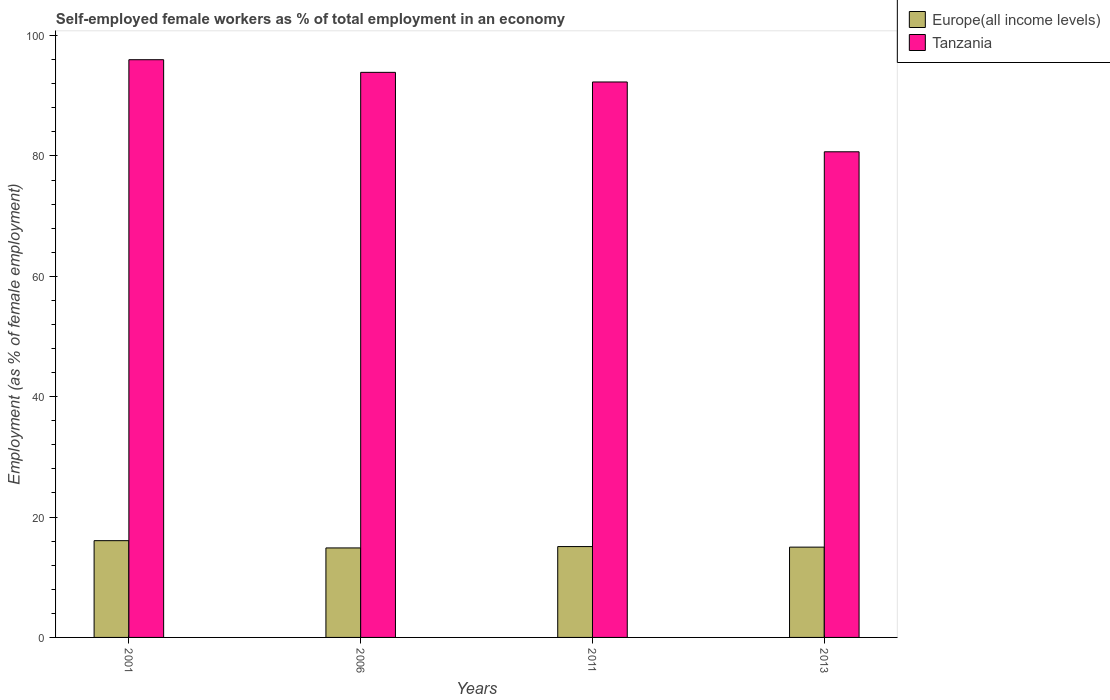How many different coloured bars are there?
Provide a short and direct response. 2. How many groups of bars are there?
Your answer should be very brief. 4. Are the number of bars on each tick of the X-axis equal?
Offer a very short reply. Yes. How many bars are there on the 4th tick from the right?
Give a very brief answer. 2. What is the label of the 1st group of bars from the left?
Ensure brevity in your answer.  2001. What is the percentage of self-employed female workers in Tanzania in 2011?
Provide a succinct answer. 92.3. Across all years, what is the maximum percentage of self-employed female workers in Tanzania?
Offer a very short reply. 96. Across all years, what is the minimum percentage of self-employed female workers in Europe(all income levels)?
Your response must be concise. 14.87. In which year was the percentage of self-employed female workers in Tanzania minimum?
Keep it short and to the point. 2013. What is the total percentage of self-employed female workers in Tanzania in the graph?
Your answer should be compact. 362.9. What is the difference between the percentage of self-employed female workers in Europe(all income levels) in 2001 and that in 2006?
Provide a short and direct response. 1.21. What is the difference between the percentage of self-employed female workers in Tanzania in 2011 and the percentage of self-employed female workers in Europe(all income levels) in 2001?
Ensure brevity in your answer.  76.22. What is the average percentage of self-employed female workers in Tanzania per year?
Offer a very short reply. 90.73. In the year 2011, what is the difference between the percentage of self-employed female workers in Tanzania and percentage of self-employed female workers in Europe(all income levels)?
Your answer should be very brief. 77.2. What is the ratio of the percentage of self-employed female workers in Europe(all income levels) in 2001 to that in 2013?
Provide a succinct answer. 1.07. Is the difference between the percentage of self-employed female workers in Tanzania in 2001 and 2006 greater than the difference between the percentage of self-employed female workers in Europe(all income levels) in 2001 and 2006?
Your answer should be compact. Yes. What is the difference between the highest and the second highest percentage of self-employed female workers in Europe(all income levels)?
Make the answer very short. 0.98. What is the difference between the highest and the lowest percentage of self-employed female workers in Europe(all income levels)?
Keep it short and to the point. 1.21. In how many years, is the percentage of self-employed female workers in Tanzania greater than the average percentage of self-employed female workers in Tanzania taken over all years?
Offer a very short reply. 3. What does the 1st bar from the left in 2013 represents?
Your answer should be compact. Europe(all income levels). What does the 2nd bar from the right in 2001 represents?
Give a very brief answer. Europe(all income levels). How many bars are there?
Keep it short and to the point. 8. Are the values on the major ticks of Y-axis written in scientific E-notation?
Provide a short and direct response. No. Does the graph contain any zero values?
Your answer should be very brief. No. Does the graph contain grids?
Your answer should be very brief. No. How many legend labels are there?
Make the answer very short. 2. How are the legend labels stacked?
Provide a succinct answer. Vertical. What is the title of the graph?
Your answer should be compact. Self-employed female workers as % of total employment in an economy. Does "Belarus" appear as one of the legend labels in the graph?
Provide a short and direct response. No. What is the label or title of the Y-axis?
Provide a succinct answer. Employment (as % of female employment). What is the Employment (as % of female employment) of Europe(all income levels) in 2001?
Offer a terse response. 16.08. What is the Employment (as % of female employment) in Tanzania in 2001?
Provide a short and direct response. 96. What is the Employment (as % of female employment) in Europe(all income levels) in 2006?
Keep it short and to the point. 14.87. What is the Employment (as % of female employment) of Tanzania in 2006?
Your answer should be compact. 93.9. What is the Employment (as % of female employment) of Europe(all income levels) in 2011?
Make the answer very short. 15.1. What is the Employment (as % of female employment) of Tanzania in 2011?
Make the answer very short. 92.3. What is the Employment (as % of female employment) in Europe(all income levels) in 2013?
Offer a very short reply. 15. What is the Employment (as % of female employment) of Tanzania in 2013?
Keep it short and to the point. 80.7. Across all years, what is the maximum Employment (as % of female employment) in Europe(all income levels)?
Make the answer very short. 16.08. Across all years, what is the maximum Employment (as % of female employment) in Tanzania?
Make the answer very short. 96. Across all years, what is the minimum Employment (as % of female employment) of Europe(all income levels)?
Your response must be concise. 14.87. Across all years, what is the minimum Employment (as % of female employment) of Tanzania?
Give a very brief answer. 80.7. What is the total Employment (as % of female employment) of Europe(all income levels) in the graph?
Provide a short and direct response. 61.05. What is the total Employment (as % of female employment) in Tanzania in the graph?
Provide a short and direct response. 362.9. What is the difference between the Employment (as % of female employment) in Europe(all income levels) in 2001 and that in 2006?
Offer a terse response. 1.21. What is the difference between the Employment (as % of female employment) of Tanzania in 2001 and that in 2006?
Your answer should be very brief. 2.1. What is the difference between the Employment (as % of female employment) of Europe(all income levels) in 2001 and that in 2011?
Your answer should be very brief. 0.98. What is the difference between the Employment (as % of female employment) of Tanzania in 2001 and that in 2011?
Make the answer very short. 3.7. What is the difference between the Employment (as % of female employment) of Europe(all income levels) in 2001 and that in 2013?
Provide a short and direct response. 1.08. What is the difference between the Employment (as % of female employment) of Europe(all income levels) in 2006 and that in 2011?
Provide a short and direct response. -0.23. What is the difference between the Employment (as % of female employment) in Europe(all income levels) in 2006 and that in 2013?
Provide a succinct answer. -0.13. What is the difference between the Employment (as % of female employment) in Europe(all income levels) in 2011 and that in 2013?
Provide a succinct answer. 0.1. What is the difference between the Employment (as % of female employment) of Tanzania in 2011 and that in 2013?
Give a very brief answer. 11.6. What is the difference between the Employment (as % of female employment) in Europe(all income levels) in 2001 and the Employment (as % of female employment) in Tanzania in 2006?
Make the answer very short. -77.82. What is the difference between the Employment (as % of female employment) of Europe(all income levels) in 2001 and the Employment (as % of female employment) of Tanzania in 2011?
Keep it short and to the point. -76.22. What is the difference between the Employment (as % of female employment) of Europe(all income levels) in 2001 and the Employment (as % of female employment) of Tanzania in 2013?
Provide a short and direct response. -64.62. What is the difference between the Employment (as % of female employment) in Europe(all income levels) in 2006 and the Employment (as % of female employment) in Tanzania in 2011?
Give a very brief answer. -77.43. What is the difference between the Employment (as % of female employment) in Europe(all income levels) in 2006 and the Employment (as % of female employment) in Tanzania in 2013?
Your response must be concise. -65.83. What is the difference between the Employment (as % of female employment) of Europe(all income levels) in 2011 and the Employment (as % of female employment) of Tanzania in 2013?
Offer a very short reply. -65.6. What is the average Employment (as % of female employment) of Europe(all income levels) per year?
Keep it short and to the point. 15.26. What is the average Employment (as % of female employment) of Tanzania per year?
Your answer should be very brief. 90.72. In the year 2001, what is the difference between the Employment (as % of female employment) of Europe(all income levels) and Employment (as % of female employment) of Tanzania?
Offer a terse response. -79.92. In the year 2006, what is the difference between the Employment (as % of female employment) in Europe(all income levels) and Employment (as % of female employment) in Tanzania?
Your answer should be compact. -79.03. In the year 2011, what is the difference between the Employment (as % of female employment) of Europe(all income levels) and Employment (as % of female employment) of Tanzania?
Your answer should be compact. -77.2. In the year 2013, what is the difference between the Employment (as % of female employment) of Europe(all income levels) and Employment (as % of female employment) of Tanzania?
Your response must be concise. -65.7. What is the ratio of the Employment (as % of female employment) of Europe(all income levels) in 2001 to that in 2006?
Offer a terse response. 1.08. What is the ratio of the Employment (as % of female employment) of Tanzania in 2001 to that in 2006?
Ensure brevity in your answer.  1.02. What is the ratio of the Employment (as % of female employment) of Europe(all income levels) in 2001 to that in 2011?
Offer a terse response. 1.06. What is the ratio of the Employment (as % of female employment) of Tanzania in 2001 to that in 2011?
Offer a very short reply. 1.04. What is the ratio of the Employment (as % of female employment) in Europe(all income levels) in 2001 to that in 2013?
Your answer should be compact. 1.07. What is the ratio of the Employment (as % of female employment) of Tanzania in 2001 to that in 2013?
Give a very brief answer. 1.19. What is the ratio of the Employment (as % of female employment) of Europe(all income levels) in 2006 to that in 2011?
Offer a very short reply. 0.98. What is the ratio of the Employment (as % of female employment) in Tanzania in 2006 to that in 2011?
Keep it short and to the point. 1.02. What is the ratio of the Employment (as % of female employment) in Tanzania in 2006 to that in 2013?
Provide a succinct answer. 1.16. What is the ratio of the Employment (as % of female employment) in Europe(all income levels) in 2011 to that in 2013?
Provide a succinct answer. 1.01. What is the ratio of the Employment (as % of female employment) of Tanzania in 2011 to that in 2013?
Give a very brief answer. 1.14. What is the difference between the highest and the second highest Employment (as % of female employment) of Europe(all income levels)?
Offer a very short reply. 0.98. What is the difference between the highest and the second highest Employment (as % of female employment) in Tanzania?
Provide a short and direct response. 2.1. What is the difference between the highest and the lowest Employment (as % of female employment) of Europe(all income levels)?
Give a very brief answer. 1.21. What is the difference between the highest and the lowest Employment (as % of female employment) of Tanzania?
Your response must be concise. 15.3. 